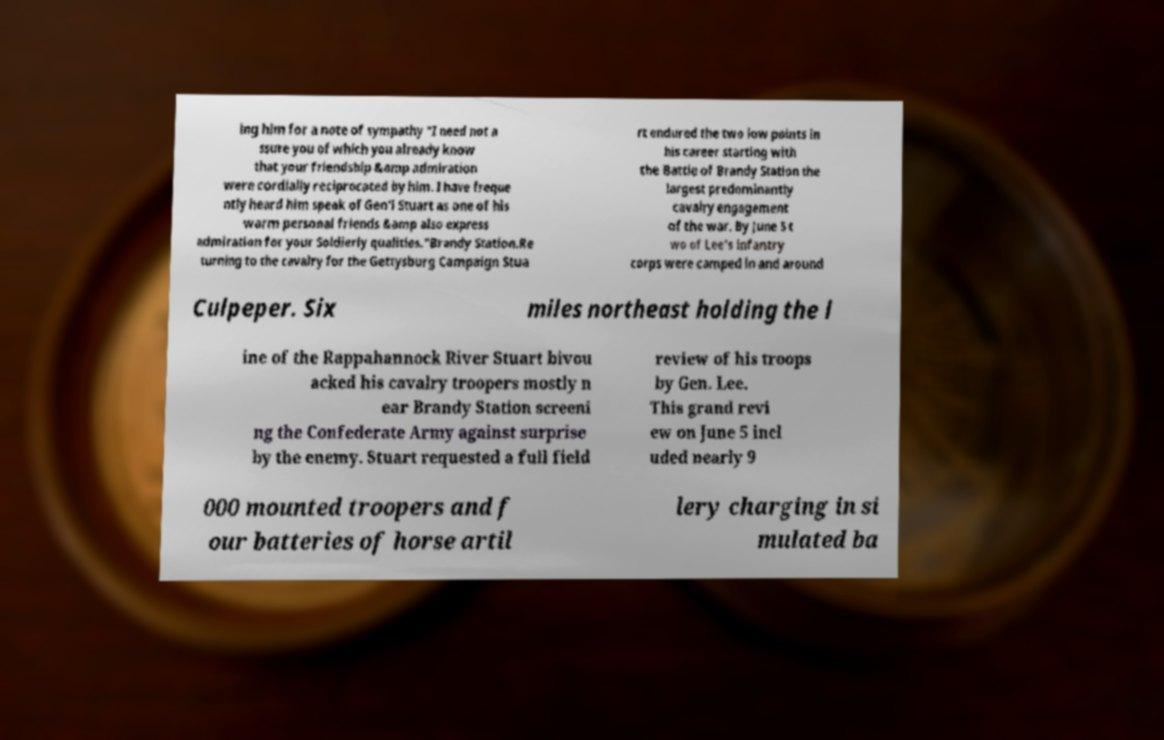There's text embedded in this image that I need extracted. Can you transcribe it verbatim? ing him for a note of sympathy "I need not a ssure you of which you already know that your friendship &amp admiration were cordially reciprocated by him. I have freque ntly heard him speak of Gen'l Stuart as one of his warm personal friends &amp also express admiration for your Soldierly qualities."Brandy Station.Re turning to the cavalry for the Gettysburg Campaign Stua rt endured the two low points in his career starting with the Battle of Brandy Station the largest predominantly cavalry engagement of the war. By June 5 t wo of Lee's infantry corps were camped in and around Culpeper. Six miles northeast holding the l ine of the Rappahannock River Stuart bivou acked his cavalry troopers mostly n ear Brandy Station screeni ng the Confederate Army against surprise by the enemy. Stuart requested a full field review of his troops by Gen. Lee. This grand revi ew on June 5 incl uded nearly 9 000 mounted troopers and f our batteries of horse artil lery charging in si mulated ba 